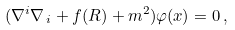<formula> <loc_0><loc_0><loc_500><loc_500>( { \nabla } ^ { i } { \nabla } _ { \, i } + f ( R ) + m ^ { 2 } ) \varphi ( x ) = 0 \, ,</formula> 